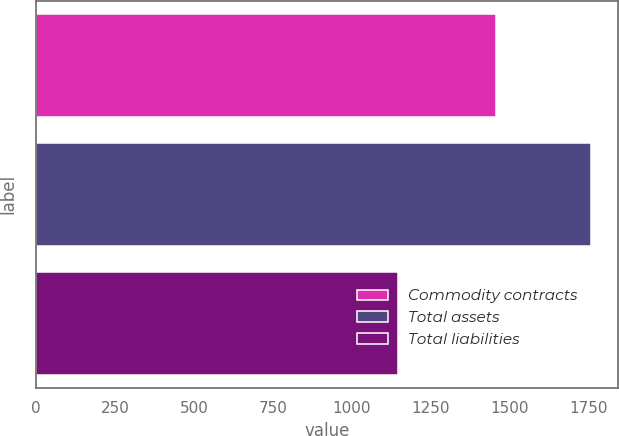Convert chart. <chart><loc_0><loc_0><loc_500><loc_500><bar_chart><fcel>Commodity contracts<fcel>Total assets<fcel>Total liabilities<nl><fcel>1457<fcel>1756<fcel>1144<nl></chart> 